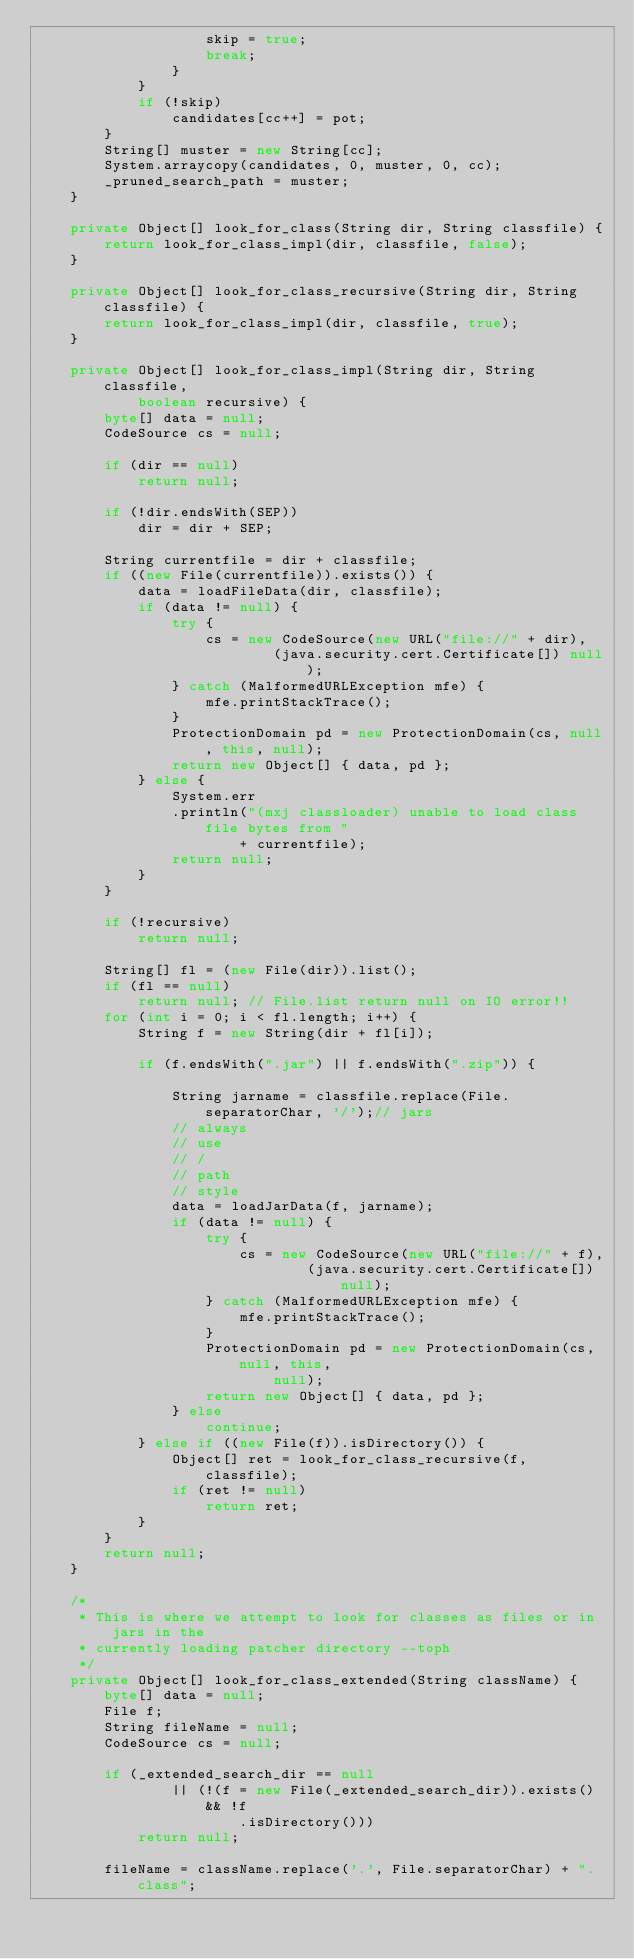<code> <loc_0><loc_0><loc_500><loc_500><_Java_>					skip = true;
					break;
				}
			}
			if (!skip)
				candidates[cc++] = pot;
		}
		String[] muster = new String[cc];
		System.arraycopy(candidates, 0, muster, 0, cc);
		_pruned_search_path = muster;
	}

	private Object[] look_for_class(String dir, String classfile) {
		return look_for_class_impl(dir, classfile, false);
	}

	private Object[] look_for_class_recursive(String dir, String classfile) {
		return look_for_class_impl(dir, classfile, true);
	}

	private Object[] look_for_class_impl(String dir, String classfile,
			boolean recursive) {
		byte[] data = null;
		CodeSource cs = null;

		if (dir == null)
			return null;

		if (!dir.endsWith(SEP))
			dir = dir + SEP;

		String currentfile = dir + classfile;
		if ((new File(currentfile)).exists()) {
			data = loadFileData(dir, classfile);
			if (data != null) {
				try {
					cs = new CodeSource(new URL("file://" + dir),
							(java.security.cert.Certificate[]) null);
				} catch (MalformedURLException mfe) {
					mfe.printStackTrace();
				}
				ProtectionDomain pd = new ProtectionDomain(cs, null, this, null);
				return new Object[] { data, pd };
			} else {
				System.err
				.println("(mxj classloader) unable to load class file bytes from "
						+ currentfile);
				return null;
			}
		}

		if (!recursive)
			return null;

		String[] fl = (new File(dir)).list();
		if (fl == null)
			return null; // File.list return null on IO error!!
		for (int i = 0; i < fl.length; i++) {
			String f = new String(dir + fl[i]);

			if (f.endsWith(".jar") || f.endsWith(".zip")) {

				String jarname = classfile.replace(File.separatorChar, '/');// jars
				// always
				// use
				// /
				// path
				// style
				data = loadJarData(f, jarname);
				if (data != null) {
					try {
						cs = new CodeSource(new URL("file://" + f),
								(java.security.cert.Certificate[]) null);
					} catch (MalformedURLException mfe) {
						mfe.printStackTrace();
					}
					ProtectionDomain pd = new ProtectionDomain(cs, null, this,
							null);
					return new Object[] { data, pd };
				} else
					continue;
			} else if ((new File(f)).isDirectory()) {
				Object[] ret = look_for_class_recursive(f, classfile);
				if (ret != null)
					return ret;
			}
		}
		return null;
	}

	/*
	 * This is where we attempt to look for classes as files or in jars in the
	 * currently loading patcher directory --toph
	 */
	private Object[] look_for_class_extended(String className) {
		byte[] data = null;
		File f;
		String fileName = null;
		CodeSource cs = null;

		if (_extended_search_dir == null
				|| (!(f = new File(_extended_search_dir)).exists() && !f
						.isDirectory()))
			return null;

		fileName = className.replace('.', File.separatorChar) + ".class";</code> 